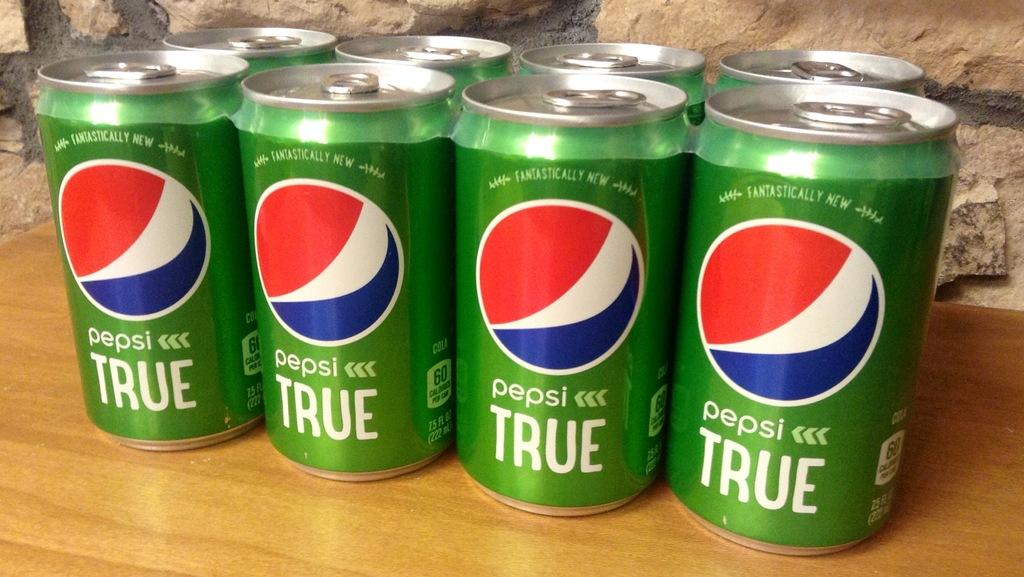<image>
Share a concise interpretation of the image provided. a six-pack of Pepsi True in green cans and red, white, and blue logo 